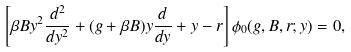Convert formula to latex. <formula><loc_0><loc_0><loc_500><loc_500>\left [ \beta B y ^ { 2 } \frac { d ^ { 2 } } { d y ^ { 2 } } + ( g + \beta B ) y \frac { d } { d y } + y - r \right ] \phi _ { 0 } ( g , B , r ; y ) = 0 ,</formula> 